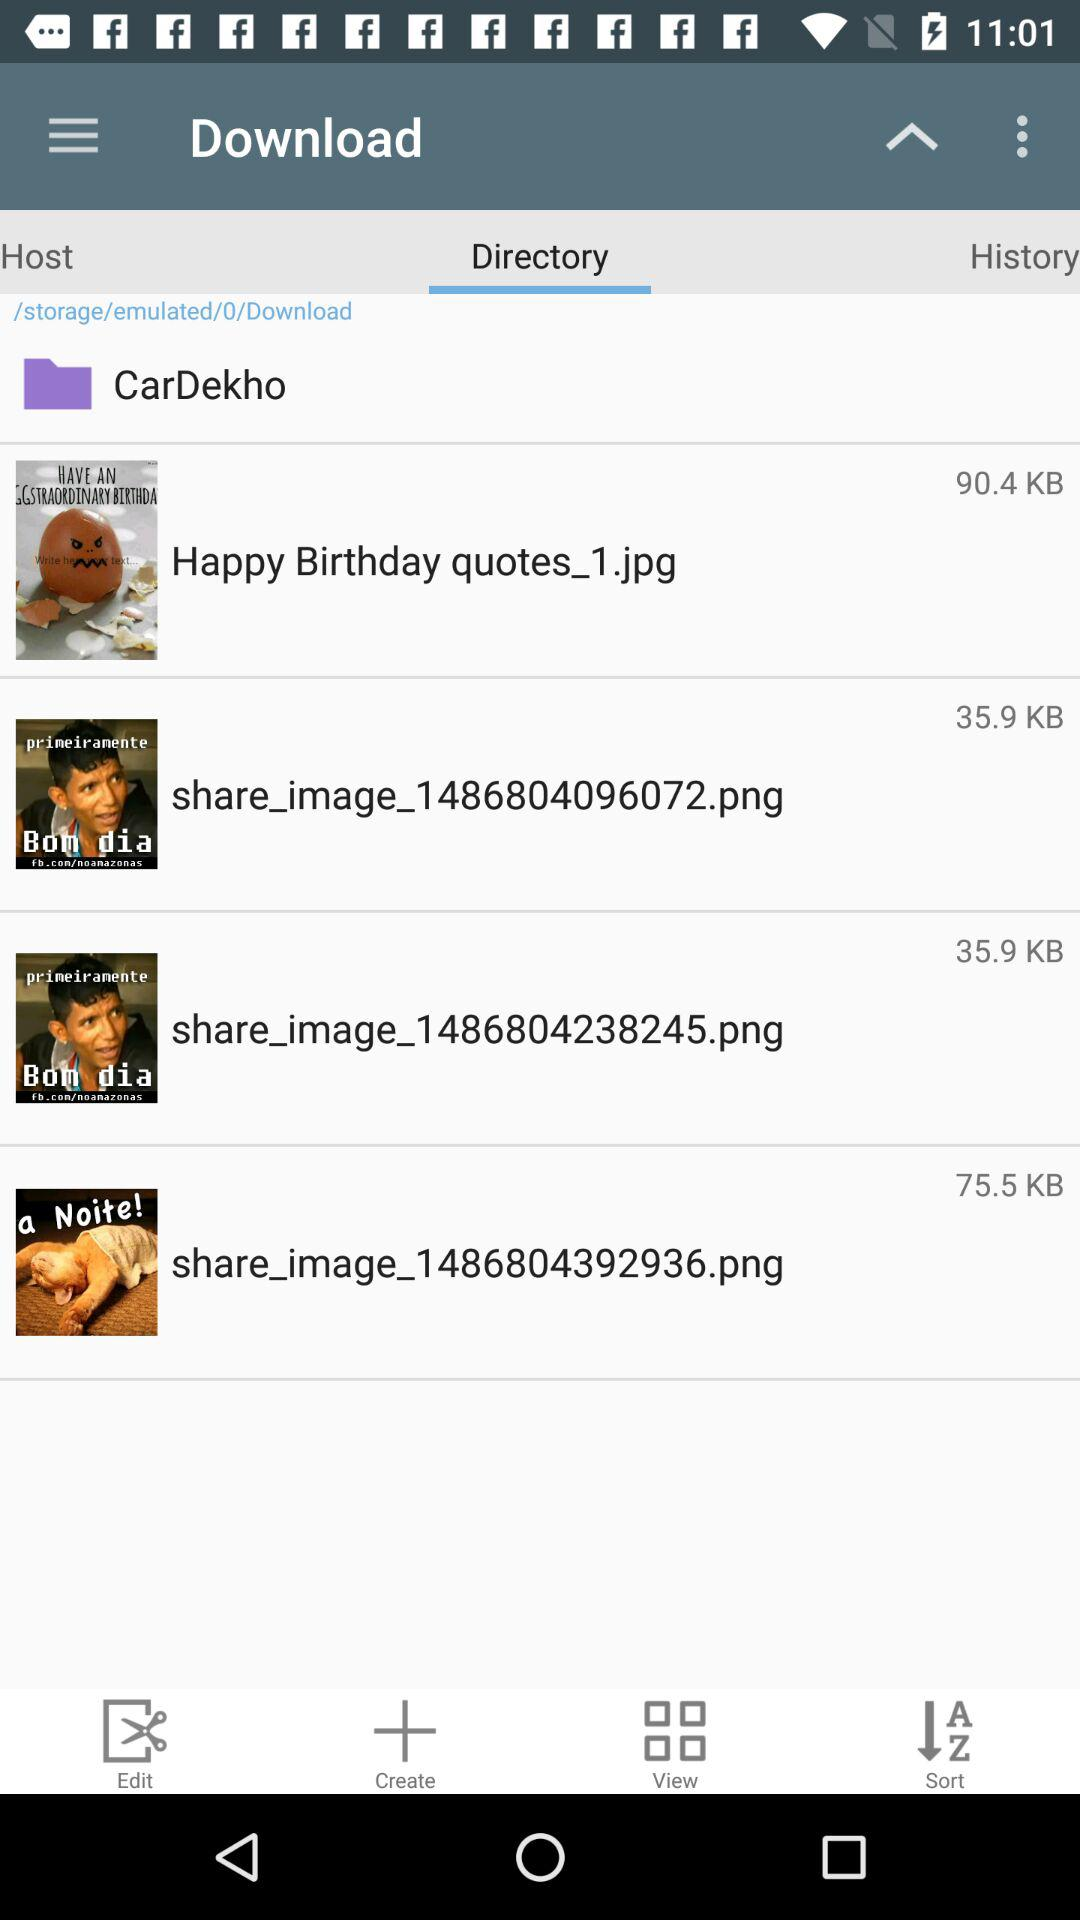How many items are in the download directory?
Answer the question using a single word or phrase. 4 